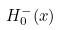<formula> <loc_0><loc_0><loc_500><loc_500>H _ { 0 } ^ { - } ( x )</formula> 